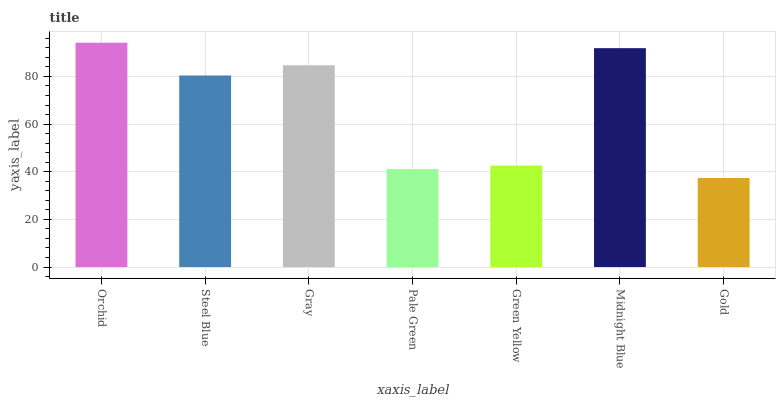Is Gold the minimum?
Answer yes or no. Yes. Is Orchid the maximum?
Answer yes or no. Yes. Is Steel Blue the minimum?
Answer yes or no. No. Is Steel Blue the maximum?
Answer yes or no. No. Is Orchid greater than Steel Blue?
Answer yes or no. Yes. Is Steel Blue less than Orchid?
Answer yes or no. Yes. Is Steel Blue greater than Orchid?
Answer yes or no. No. Is Orchid less than Steel Blue?
Answer yes or no. No. Is Steel Blue the high median?
Answer yes or no. Yes. Is Steel Blue the low median?
Answer yes or no. Yes. Is Green Yellow the high median?
Answer yes or no. No. Is Pale Green the low median?
Answer yes or no. No. 